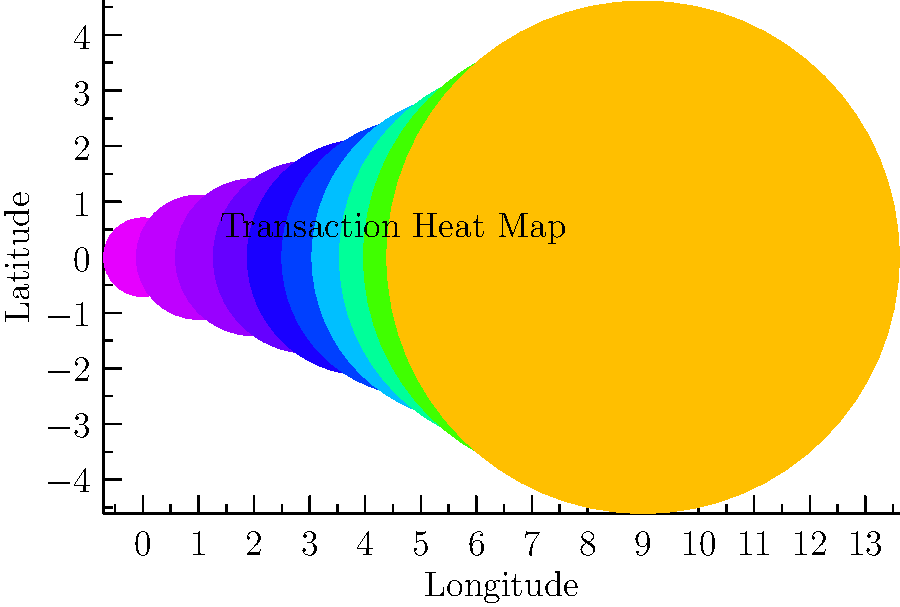As a bank manager investigating suspicious activity, you've generated a heat map of transaction locations for a client's account. The map shows circles of varying sizes and colors, with larger and warmer-colored circles indicating higher transaction volumes. What does the pattern of circles along the x-axis suggest about the client's transaction behavior? To interpret the heat map and answer the question, let's analyze the pattern step-by-step:

1. Observe the x-axis: It represents longitude, which indicates the east-west position of transactions.

2. Observe the y-axis: It represents latitude, which indicates the north-south position of transactions.

3. Analyze the circle sizes: Larger circles represent higher transaction volumes.

4. Analyze the circle colors: Warmer colors (red, orange) indicate higher transaction volumes, while cooler colors (blue, green) indicate lower volumes.

5. Observe the pattern: The circles are arranged in a straight line along the x-axis (longitude) at y = 0.

6. Interpret the pattern: This suggests that all transactions are occurring at the same latitude but at different longitudes.

7. Observe the progression: From left to right, the circles become larger and their colors become warmer.

8. Interpret the progression: This indicates that transaction volumes are increasing from west to east.

9. Consider the implications: The client's transactions are concentrated along a single latitude, possibly following a specific route or targeting a particular region. The increasing volume towards the east could suggest a pattern of activity that intensifies in a specific direction.

Given this analysis, we can conclude that the client's transaction behavior shows a clear geographical pattern with increasing volumes from west to east along a single latitude.
Answer: Increasing transaction volumes from west to east along a single latitude 